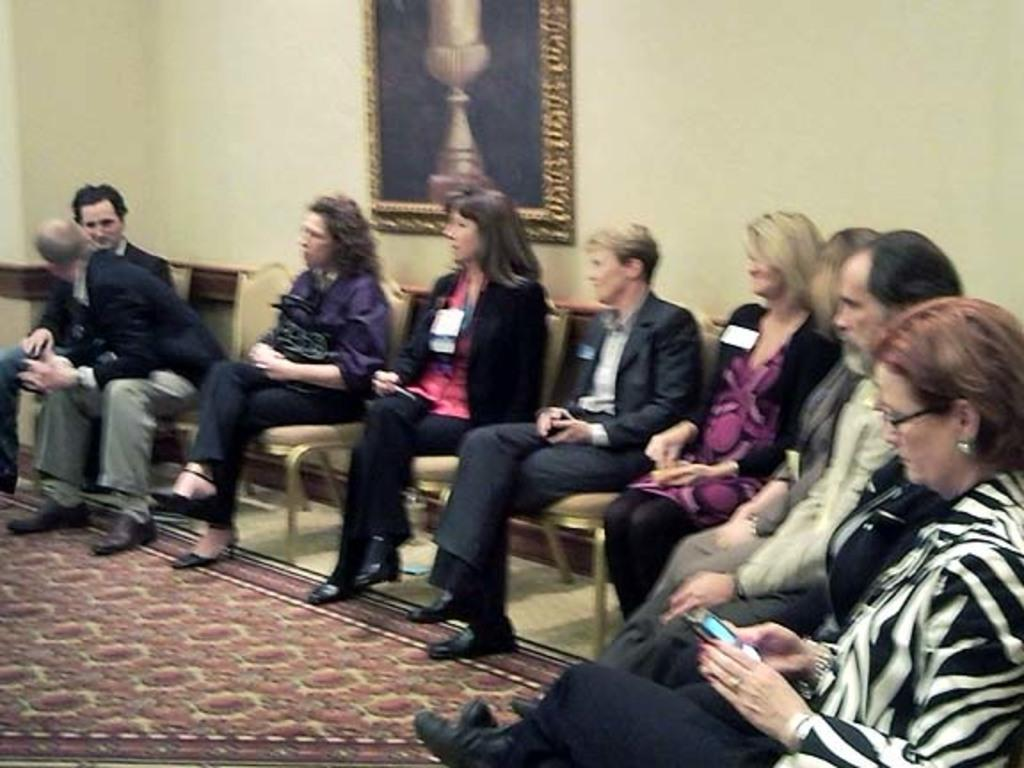What are the people in the image doing? The people in the image are sitting. What can be seen in the background of the image? There is a wall in the background of the image. Is there any decoration or object on the wall? Yes, there is a frame placed on the wall. What is at the bottom of the image? There is a carpet at the bottom of the image. How many jellyfish are swimming in the carpet in the image? There are no jellyfish present in the image, and the carpet is not a body of water where jellyfish could swim. 